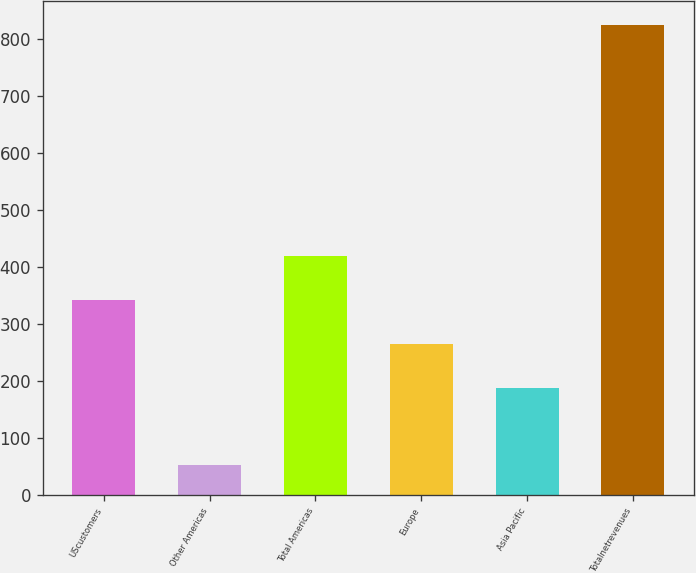Convert chart. <chart><loc_0><loc_0><loc_500><loc_500><bar_chart><fcel>UScustomers<fcel>Other Americas<fcel>Total Americas<fcel>Europe<fcel>Asia Pacific<fcel>Totalnetrevenues<nl><fcel>341.78<fcel>52.5<fcel>419.02<fcel>264.54<fcel>187.3<fcel>824.9<nl></chart> 